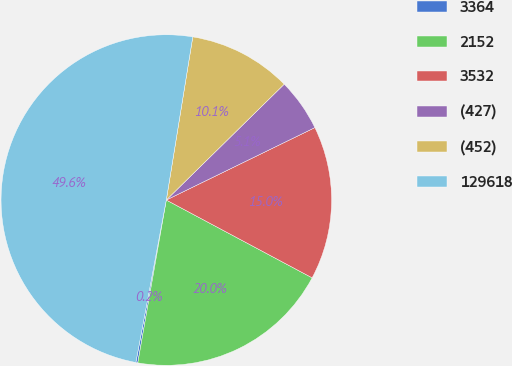Convert chart. <chart><loc_0><loc_0><loc_500><loc_500><pie_chart><fcel>3364<fcel>2152<fcel>3532<fcel>(427)<fcel>(452)<fcel>129618<nl><fcel>0.19%<fcel>19.96%<fcel>15.02%<fcel>5.14%<fcel>10.08%<fcel>49.61%<nl></chart> 